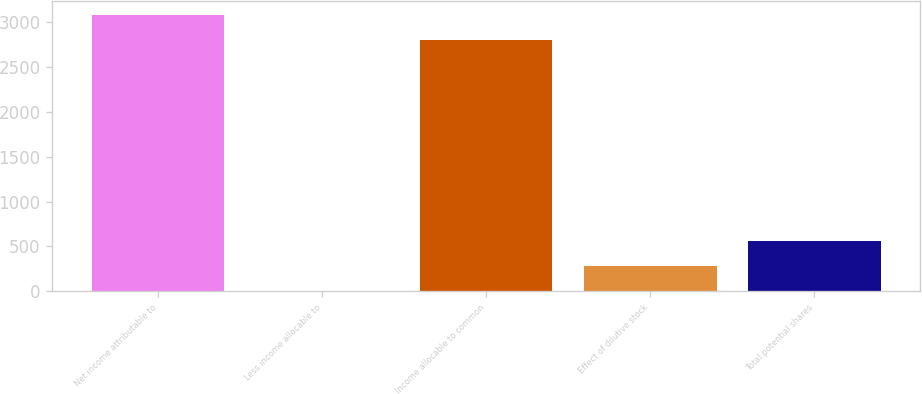Convert chart. <chart><loc_0><loc_0><loc_500><loc_500><bar_chart><fcel>Net income attributable to<fcel>Less income allocable to<fcel>Income allocable to common<fcel>Effect of dilutive stock<fcel>Total potential shares<nl><fcel>3078.79<fcel>1<fcel>2798.9<fcel>280.89<fcel>560.78<nl></chart> 